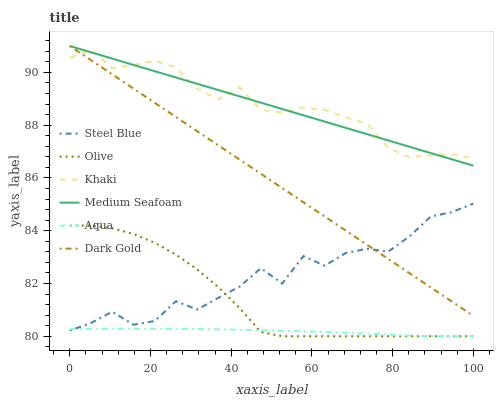Does Aqua have the minimum area under the curve?
Answer yes or no. Yes. Does Khaki have the maximum area under the curve?
Answer yes or no. Yes. Does Dark Gold have the minimum area under the curve?
Answer yes or no. No. Does Dark Gold have the maximum area under the curve?
Answer yes or no. No. Is Dark Gold the smoothest?
Answer yes or no. Yes. Is Steel Blue the roughest?
Answer yes or no. Yes. Is Aqua the smoothest?
Answer yes or no. No. Is Aqua the roughest?
Answer yes or no. No. Does Aqua have the lowest value?
Answer yes or no. Yes. Does Dark Gold have the lowest value?
Answer yes or no. No. Does Medium Seafoam have the highest value?
Answer yes or no. Yes. Does Aqua have the highest value?
Answer yes or no. No. Is Aqua less than Dark Gold?
Answer yes or no. Yes. Is Khaki greater than Olive?
Answer yes or no. Yes. Does Aqua intersect Steel Blue?
Answer yes or no. Yes. Is Aqua less than Steel Blue?
Answer yes or no. No. Is Aqua greater than Steel Blue?
Answer yes or no. No. Does Aqua intersect Dark Gold?
Answer yes or no. No. 